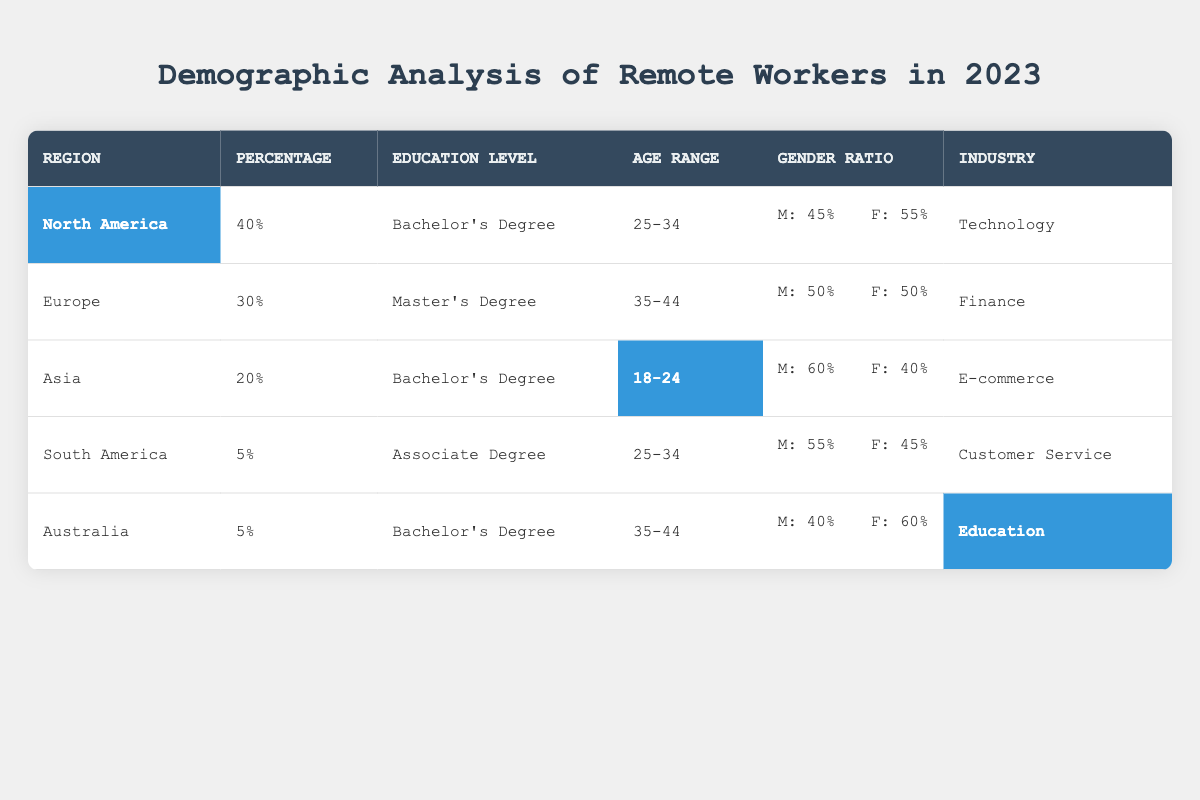What percentage of remote workers come from North America? The table clearly shows that North America has a highlighted percentage of 40%, indicating that 40% of remote workers are from this region.
Answer: 40% Which industry has the highest percentage of remote workers? By reviewing the percentages in the table, North America (40%) is the highest, associated with the Technology industry.
Answer: Technology What is the gender ratio for remote workers in Asia? The gender ratio for Asia is indicated as male 60% and female 40%, showing a significant skew towards a higher percentage of males.
Answer: Male: 60%, Female: 40% Does South America have a higher percentage of remote workers than Australia? Comparing the percentages, South America has 5% and Australia also has 5%. Therefore, they are equal, not higher.
Answer: No What is the average age range for remote workers in North America and Europe combined? The age ranges for North America (25-34) and Europe (35-44) are assessed; the average calculated is (29.5 + 39.5)/2 = 34
Answer: 34 Which region has the lowest percentage of remote workers and what is the related education level? The lowest percentage (5%) is from both South America and Australia; their education levels are Associate Degree and Bachelor's Degree, respectively.
Answer: 5% (South America), Associate Degree In which region do remote workers predominantly have a Master's Degree? Reviewing the table, Europe is identified as having a predominantly Master's Degree, associated with 30% of the remote workers.
Answer: Europe Is the industry for remote workers in Asia the same as that in South America? Asia's industry is E-commerce while South America is Customer Service, thus they are different.
Answer: No What is the difference in gender representation between North America and Asia? North America's gender ratio is 45% male and 55% female, while Asia has 60% male and 40% female; the difference highlights North America has 10% more females.
Answer: 10% more females in North America If we consider all regions, what is the total percentage accounted for by remote workers with an Associate Degree? Only South America has remote workers with an Associate Degree, accounting for 5% of the total.
Answer: 5% 